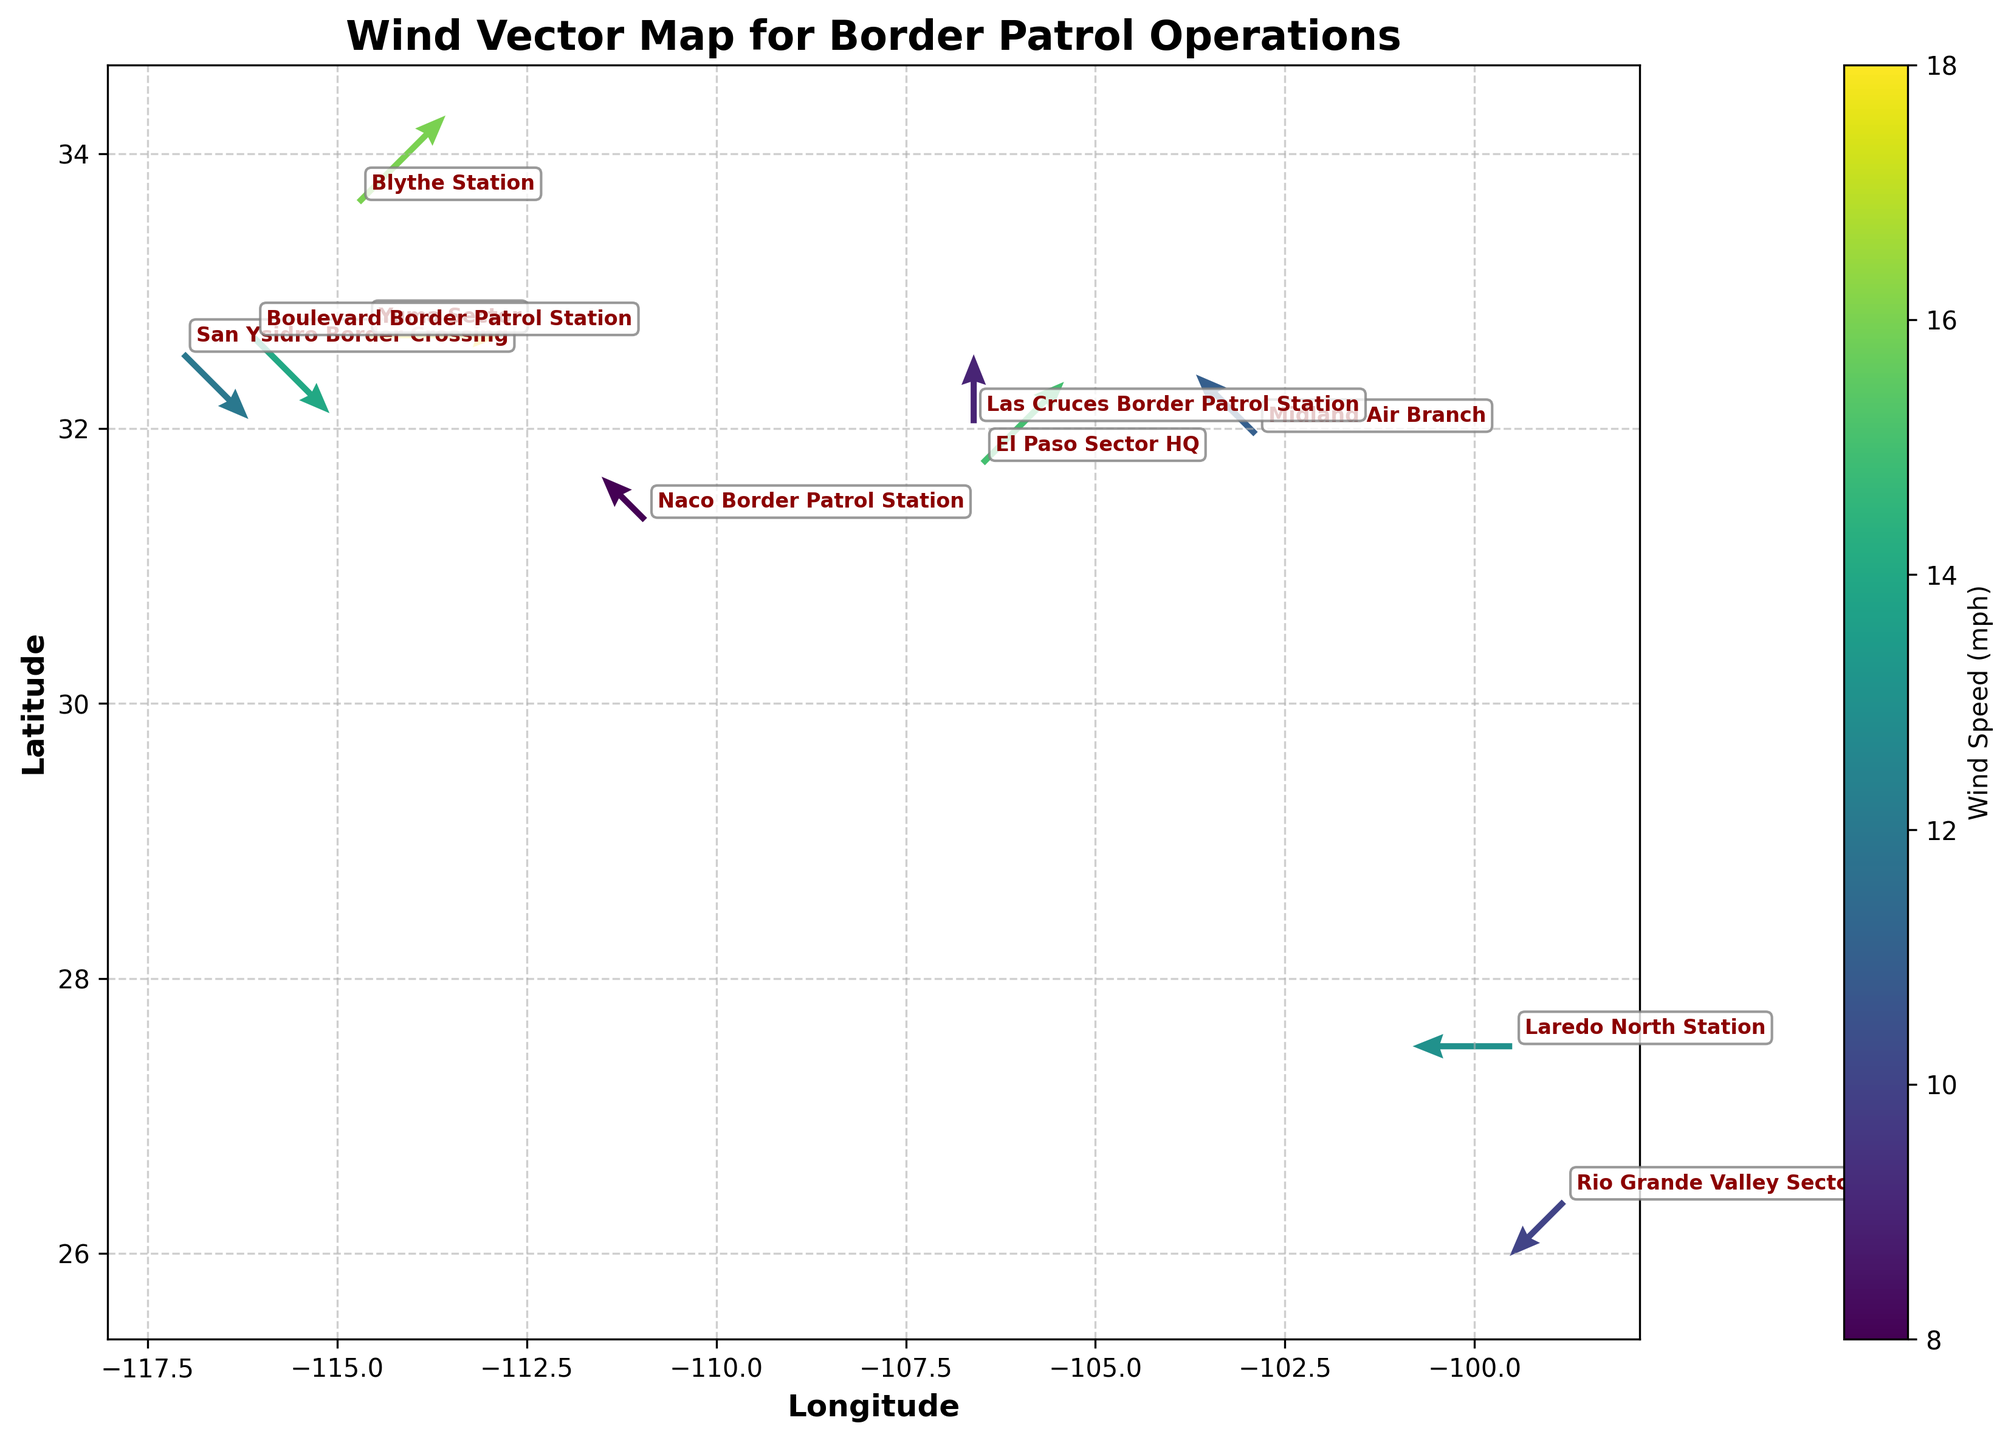What is the title of the figure? The title is usually located at the top of the figure, above the plot area. Here, it reads 'Wind Vector Map for Border Patrol Operations'.
Answer: Wind Vector Map for Border Patrol Operations How many border patrol locations are represented in the figure? Count the number of unique location labels annotated on the figure. According to the data, there are ten distinct locations.
Answer: 10 What wind speed range appears on the colorbar? Look at the colorbar adjacent to the plot area. It shows a spectral range that visually indicates the minimum and maximum wind speed values.
Answer: 8-18 mph In which direction is the wind blowing at the El Paso Sector HQ? Locate the El Paso Sector HQ label on the map and observe the wind vector's direction from this point. The arrow points toward the southwest (SW).
Answer: SW Which location has the highest recorded wind speed, and what is that speed? Identify the longest arrow, which indicates the highest wind speed, on the figure. The label beside this arrow shows it's from the Yuma Sector with a speed of 18 mph.
Answer: Yuma Sector, 18 mph What is the wind vector magnitude (speed) at Laredo North Station? Check the color and length of the arrow near Laredo North Station. Comparing it with the color bar, the speed is 13 mph.
Answer: 13 mph Compare the wind directions at San Ysidro Border Crossing and Boulevard Border Patrol Station. What are they? Identify both locations and observe the arrow directions. San Ysidro indicates a northwest (NW) direction, and Boulevard also shows a northwest (NW) direction.
Answer: Both are NW Which location has the lowest mean wind speed, and what is this speed? Evaluate the wind speed values at all locations. The Naco Border Patrol Station has the lowest speed of 8 mph, as indicated by a shorter arrow and the color representation.
Answer: Naco Border Patrol Station, 8 mph What is the mean wind speed across all locations? Sum all wind speeds (12 + 8 + 15 + 18 + 10 + 14 + 11 + 9 + 13 + 16 = 126 mph) and divide by the number of locations (10). 126 / 10 = 12.6 mph.
Answer: 12.6 mph Which sector has wind vectors pointing in the most different direction compared to the others? Compare the orientations of all arrows. The direction at Las Cruces Border Patrol Station points south (S), which is distinct since most others point in other directions.
Answer: Las Cruces Border Patrol Station 